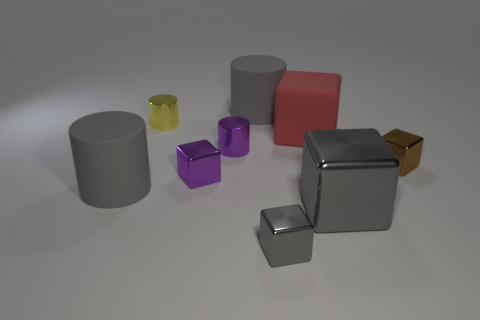Is there a blue rubber object of the same size as the yellow thing?
Offer a terse response. No. There is a matte thing that is in front of the red block; is it the same shape as the big metal thing?
Make the answer very short. No. The big shiny block has what color?
Your response must be concise. Gray. What shape is the small thing that is the same color as the big shiny block?
Provide a succinct answer. Cube. Is there a big metal thing?
Your answer should be compact. Yes. There is a brown thing that is made of the same material as the small purple cylinder; what is its size?
Provide a succinct answer. Small. There is a brown thing that is right of the big rubber cylinder that is on the left side of the gray cylinder behind the small brown metal block; what shape is it?
Your answer should be compact. Cube. Is the number of red rubber objects that are in front of the tiny yellow shiny object the same as the number of big cylinders?
Make the answer very short. No. What is the size of the other cube that is the same color as the big shiny block?
Keep it short and to the point. Small. Is the large metal thing the same shape as the tiny yellow metal object?
Provide a succinct answer. No. 